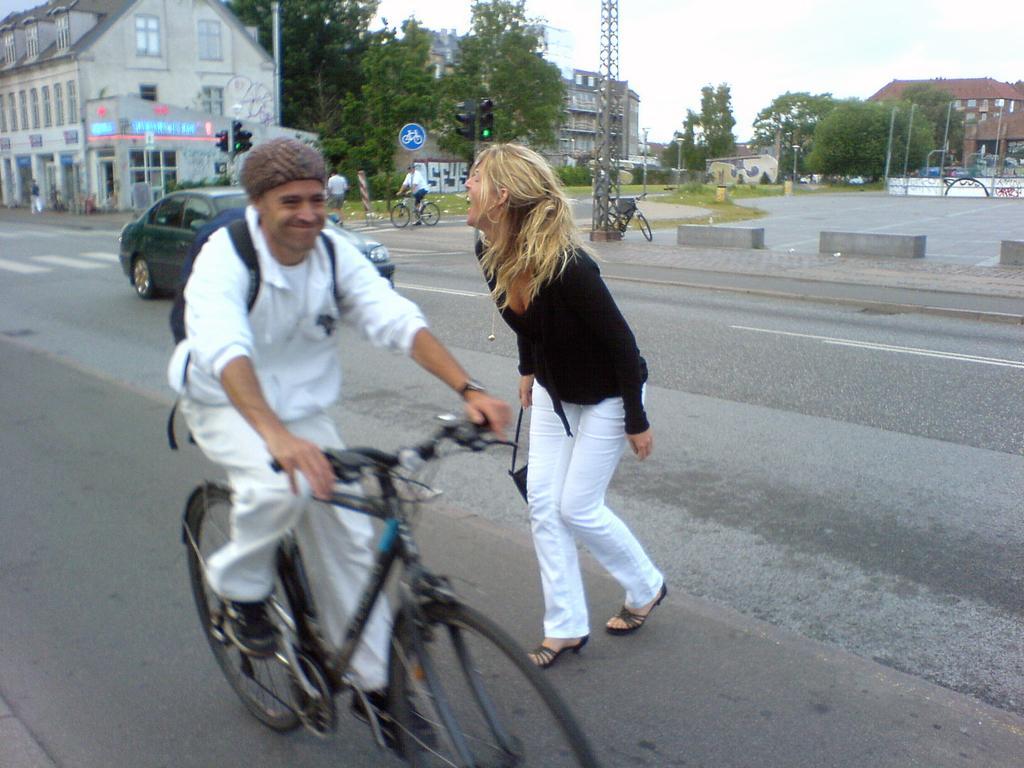Can you describe this image briefly? Here in the front we can see a man riding a bicycle is a backpack on him beside in we can see a women both of them laughing and behind them we can see a car ,a building and trees that there are other people who are standing and sitting on a bicycle is present and there are other buildings also present 